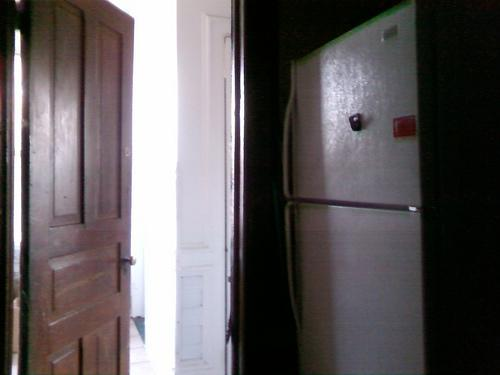Question: what is on top of the fridge part?
Choices:
A. Freezer.
B. Ice box.
C. Cooler.
D. Cold storage.
Answer with the letter. Answer: A Question: what color is the door?
Choices:
A. Blue.
B. Green.
C. White.
D. Brown.
Answer with the letter. Answer: D Question: what color is the fridge?
Choices:
A. White.
B. Brown.
C. Black.
D. Yellow.
Answer with the letter. Answer: A Question: where are the magnets?
Choices:
A. On the blackboard.
B. On fridge.
C. On the whiteboard.
D. In the drawer.
Answer with the letter. Answer: B 